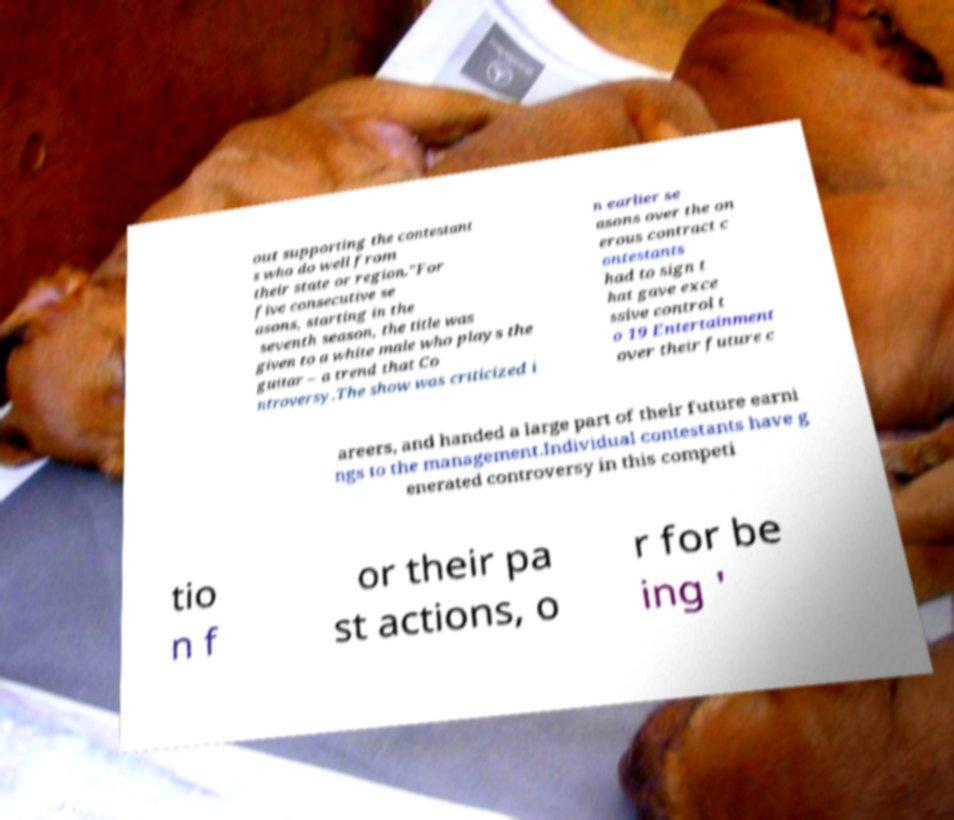Please identify and transcribe the text found in this image. out supporting the contestant s who do well from their state or region."For five consecutive se asons, starting in the seventh season, the title was given to a white male who plays the guitar – a trend that Co ntroversy.The show was criticized i n earlier se asons over the on erous contract c ontestants had to sign t hat gave exce ssive control t o 19 Entertainment over their future c areers, and handed a large part of their future earni ngs to the management.Individual contestants have g enerated controversy in this competi tio n f or their pa st actions, o r for be ing ' 